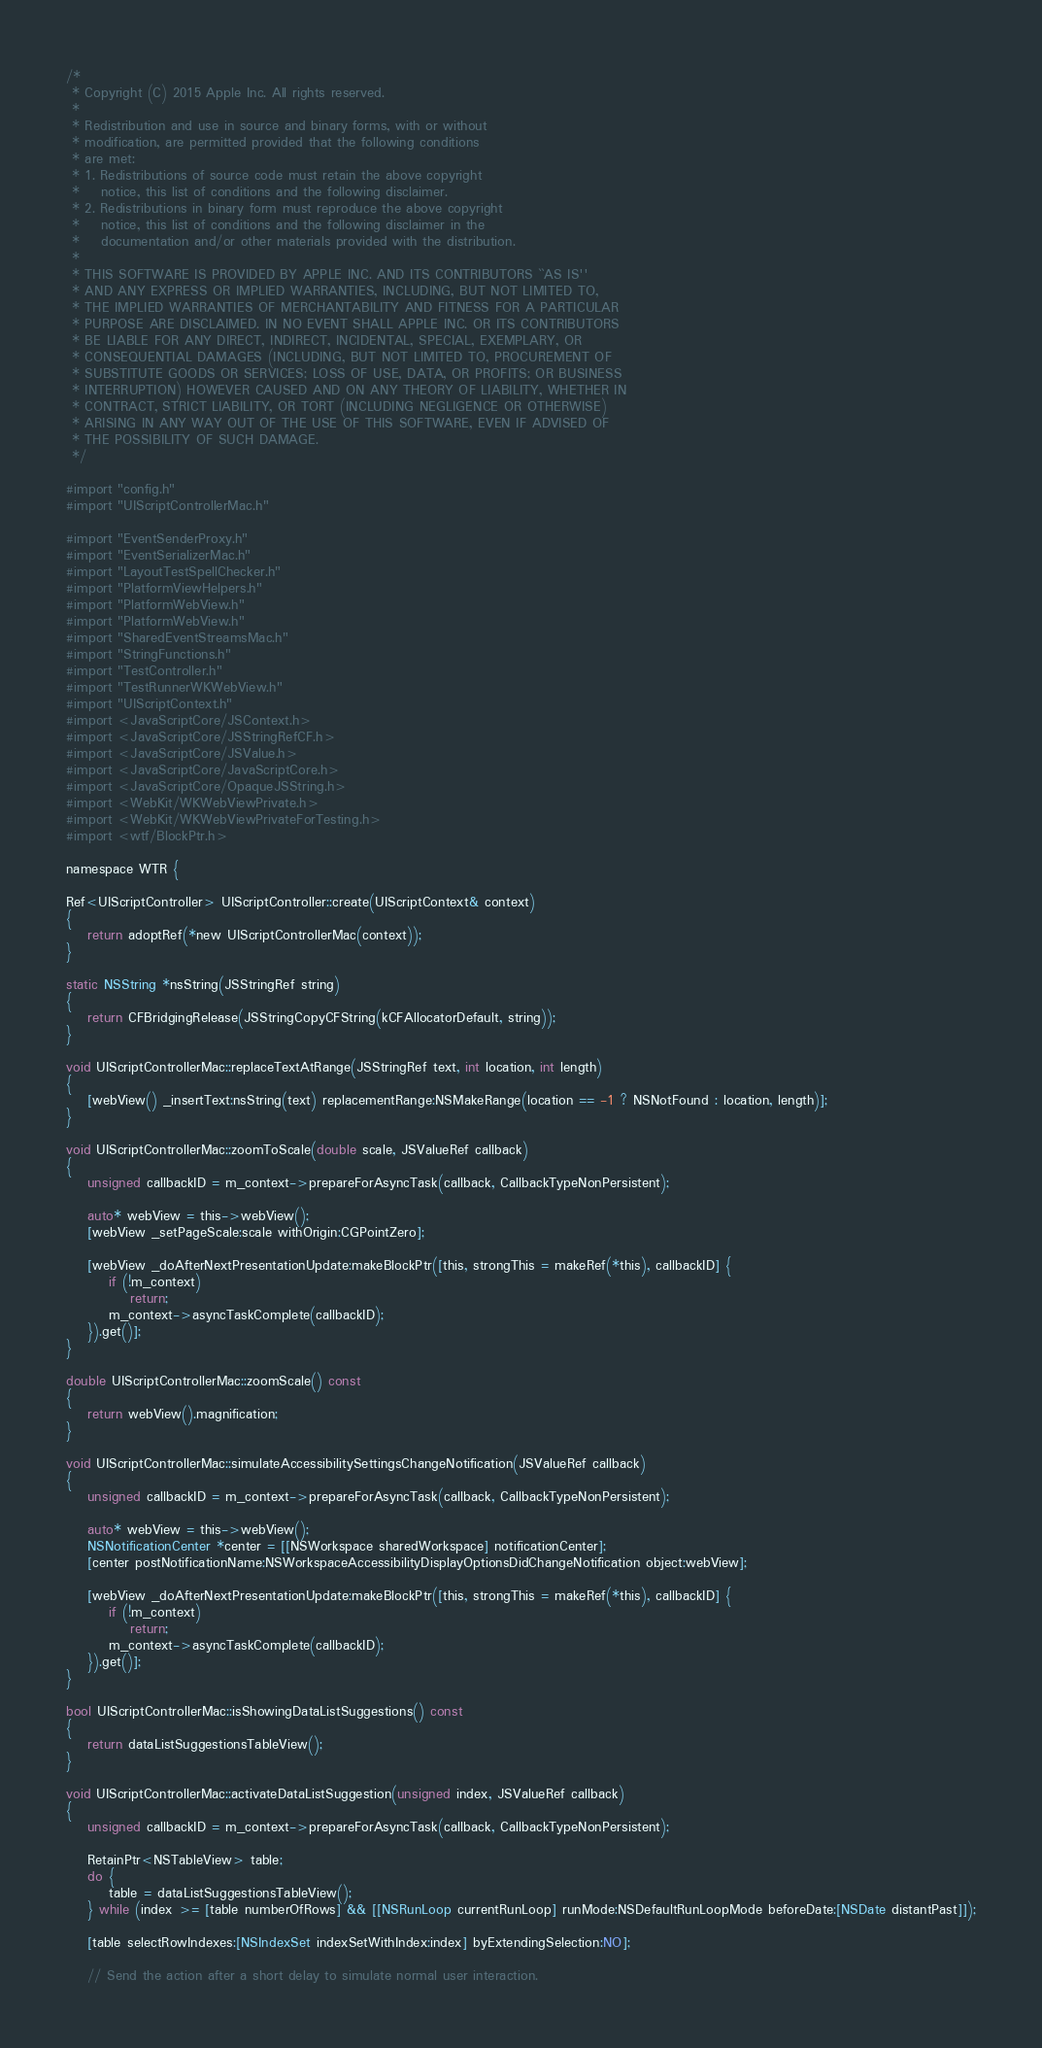Convert code to text. <code><loc_0><loc_0><loc_500><loc_500><_ObjectiveC_>/*
 * Copyright (C) 2015 Apple Inc. All rights reserved.
 *
 * Redistribution and use in source and binary forms, with or without
 * modification, are permitted provided that the following conditions
 * are met:
 * 1. Redistributions of source code must retain the above copyright
 *    notice, this list of conditions and the following disclaimer.
 * 2. Redistributions in binary form must reproduce the above copyright
 *    notice, this list of conditions and the following disclaimer in the
 *    documentation and/or other materials provided with the distribution.
 *
 * THIS SOFTWARE IS PROVIDED BY APPLE INC. AND ITS CONTRIBUTORS ``AS IS''
 * AND ANY EXPRESS OR IMPLIED WARRANTIES, INCLUDING, BUT NOT LIMITED TO,
 * THE IMPLIED WARRANTIES OF MERCHANTABILITY AND FITNESS FOR A PARTICULAR
 * PURPOSE ARE DISCLAIMED. IN NO EVENT SHALL APPLE INC. OR ITS CONTRIBUTORS
 * BE LIABLE FOR ANY DIRECT, INDIRECT, INCIDENTAL, SPECIAL, EXEMPLARY, OR
 * CONSEQUENTIAL DAMAGES (INCLUDING, BUT NOT LIMITED TO, PROCUREMENT OF
 * SUBSTITUTE GOODS OR SERVICES; LOSS OF USE, DATA, OR PROFITS; OR BUSINESS
 * INTERRUPTION) HOWEVER CAUSED AND ON ANY THEORY OF LIABILITY, WHETHER IN
 * CONTRACT, STRICT LIABILITY, OR TORT (INCLUDING NEGLIGENCE OR OTHERWISE)
 * ARISING IN ANY WAY OUT OF THE USE OF THIS SOFTWARE, EVEN IF ADVISED OF
 * THE POSSIBILITY OF SUCH DAMAGE.
 */

#import "config.h"
#import "UIScriptControllerMac.h"

#import "EventSenderProxy.h"
#import "EventSerializerMac.h"
#import "LayoutTestSpellChecker.h"
#import "PlatformViewHelpers.h"
#import "PlatformWebView.h"
#import "PlatformWebView.h"
#import "SharedEventStreamsMac.h"
#import "StringFunctions.h"
#import "TestController.h"
#import "TestRunnerWKWebView.h"
#import "UIScriptContext.h"
#import <JavaScriptCore/JSContext.h>
#import <JavaScriptCore/JSStringRefCF.h>
#import <JavaScriptCore/JSValue.h>
#import <JavaScriptCore/JavaScriptCore.h>
#import <JavaScriptCore/OpaqueJSString.h>
#import <WebKit/WKWebViewPrivate.h>
#import <WebKit/WKWebViewPrivateForTesting.h>
#import <wtf/BlockPtr.h>

namespace WTR {

Ref<UIScriptController> UIScriptController::create(UIScriptContext& context)
{
    return adoptRef(*new UIScriptControllerMac(context));
}

static NSString *nsString(JSStringRef string)
{
    return CFBridgingRelease(JSStringCopyCFString(kCFAllocatorDefault, string));
}

void UIScriptControllerMac::replaceTextAtRange(JSStringRef text, int location, int length)
{
    [webView() _insertText:nsString(text) replacementRange:NSMakeRange(location == -1 ? NSNotFound : location, length)];
}

void UIScriptControllerMac::zoomToScale(double scale, JSValueRef callback)
{
    unsigned callbackID = m_context->prepareForAsyncTask(callback, CallbackTypeNonPersistent);

    auto* webView = this->webView();
    [webView _setPageScale:scale withOrigin:CGPointZero];

    [webView _doAfterNextPresentationUpdate:makeBlockPtr([this, strongThis = makeRef(*this), callbackID] {
        if (!m_context)
            return;
        m_context->asyncTaskComplete(callbackID);
    }).get()];
}

double UIScriptControllerMac::zoomScale() const
{
    return webView().magnification;
}

void UIScriptControllerMac::simulateAccessibilitySettingsChangeNotification(JSValueRef callback)
{
    unsigned callbackID = m_context->prepareForAsyncTask(callback, CallbackTypeNonPersistent);

    auto* webView = this->webView();
    NSNotificationCenter *center = [[NSWorkspace sharedWorkspace] notificationCenter];
    [center postNotificationName:NSWorkspaceAccessibilityDisplayOptionsDidChangeNotification object:webView];

    [webView _doAfterNextPresentationUpdate:makeBlockPtr([this, strongThis = makeRef(*this), callbackID] {
        if (!m_context)
            return;
        m_context->asyncTaskComplete(callbackID);
    }).get()];
}

bool UIScriptControllerMac::isShowingDataListSuggestions() const
{
    return dataListSuggestionsTableView();
}

void UIScriptControllerMac::activateDataListSuggestion(unsigned index, JSValueRef callback)
{
    unsigned callbackID = m_context->prepareForAsyncTask(callback, CallbackTypeNonPersistent);

    RetainPtr<NSTableView> table;
    do {
        table = dataListSuggestionsTableView();
    } while (index >= [table numberOfRows] && [[NSRunLoop currentRunLoop] runMode:NSDefaultRunLoopMode beforeDate:[NSDate distantPast]]);

    [table selectRowIndexes:[NSIndexSet indexSetWithIndex:index] byExtendingSelection:NO];

    // Send the action after a short delay to simulate normal user interaction.</code> 